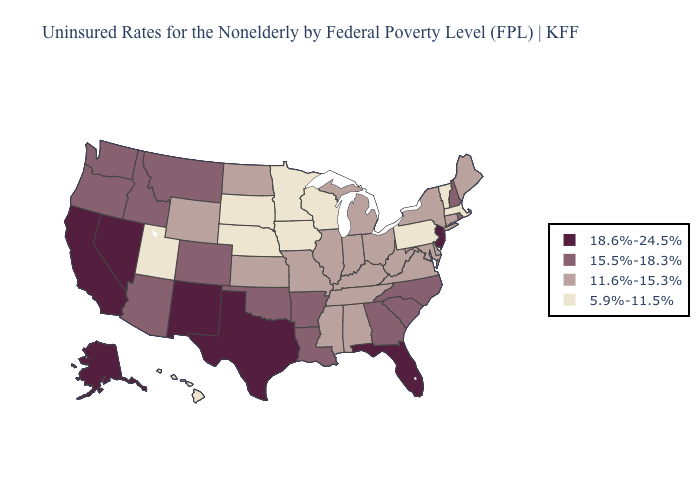What is the value of Alabama?
Be succinct. 11.6%-15.3%. Is the legend a continuous bar?
Write a very short answer. No. Does Nebraska have the highest value in the USA?
Quick response, please. No. What is the lowest value in the Northeast?
Quick response, please. 5.9%-11.5%. What is the lowest value in the USA?
Keep it brief. 5.9%-11.5%. Does New Jersey have the highest value in the USA?
Answer briefly. Yes. Which states have the lowest value in the USA?
Be succinct. Hawaii, Iowa, Massachusetts, Minnesota, Nebraska, Pennsylvania, South Dakota, Utah, Vermont, Wisconsin. What is the value of Arkansas?
Quick response, please. 15.5%-18.3%. Does Wisconsin have the highest value in the MidWest?
Answer briefly. No. Does Kentucky have a higher value than Wyoming?
Keep it brief. No. Which states hav the highest value in the West?
Concise answer only. Alaska, California, Nevada, New Mexico. Among the states that border Iowa , which have the lowest value?
Short answer required. Minnesota, Nebraska, South Dakota, Wisconsin. Which states have the highest value in the USA?
Give a very brief answer. Alaska, California, Florida, Nevada, New Jersey, New Mexico, Texas. What is the value of Minnesota?
Answer briefly. 5.9%-11.5%. What is the lowest value in the USA?
Keep it brief. 5.9%-11.5%. 